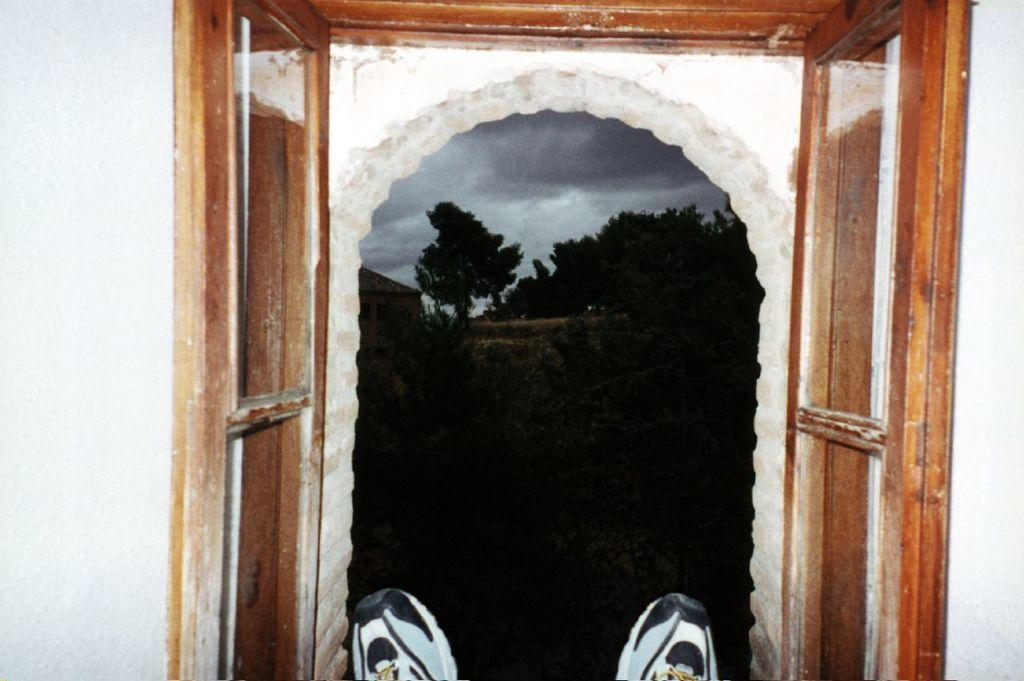What can be seen in the image that provides a view of the outdoors? There is a window in the image that provides a view of the outdoors. What objects are near the window? Shoes are near the window. What can be seen in the background of the image? There are trees, a building, and the sky visible in the background of the image. What is the condition of the sky in the image? Clouds are present in the sky, which is visible in the background of the image. How many worms can be seen crawling on the shoes in the image? There are no worms present in the image; it only shows shoes near the window. 